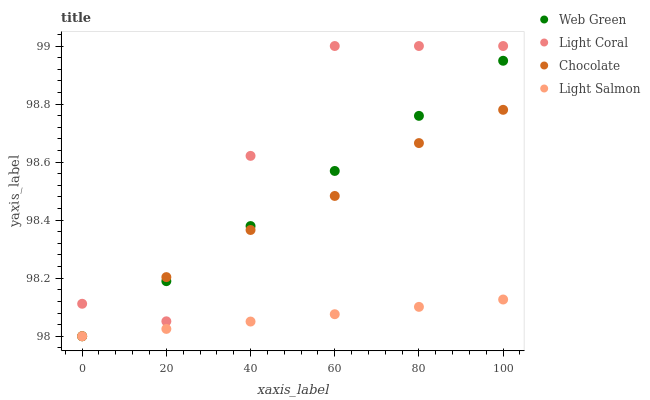Does Light Salmon have the minimum area under the curve?
Answer yes or no. Yes. Does Light Coral have the maximum area under the curve?
Answer yes or no. Yes. Does Web Green have the minimum area under the curve?
Answer yes or no. No. Does Web Green have the maximum area under the curve?
Answer yes or no. No. Is Light Salmon the smoothest?
Answer yes or no. Yes. Is Light Coral the roughest?
Answer yes or no. Yes. Is Web Green the smoothest?
Answer yes or no. No. Is Web Green the roughest?
Answer yes or no. No. Does Light Salmon have the lowest value?
Answer yes or no. Yes. Does Light Coral have the highest value?
Answer yes or no. Yes. Does Web Green have the highest value?
Answer yes or no. No. Is Light Salmon less than Light Coral?
Answer yes or no. Yes. Is Light Coral greater than Light Salmon?
Answer yes or no. Yes. Does Light Coral intersect Web Green?
Answer yes or no. Yes. Is Light Coral less than Web Green?
Answer yes or no. No. Is Light Coral greater than Web Green?
Answer yes or no. No. Does Light Salmon intersect Light Coral?
Answer yes or no. No. 